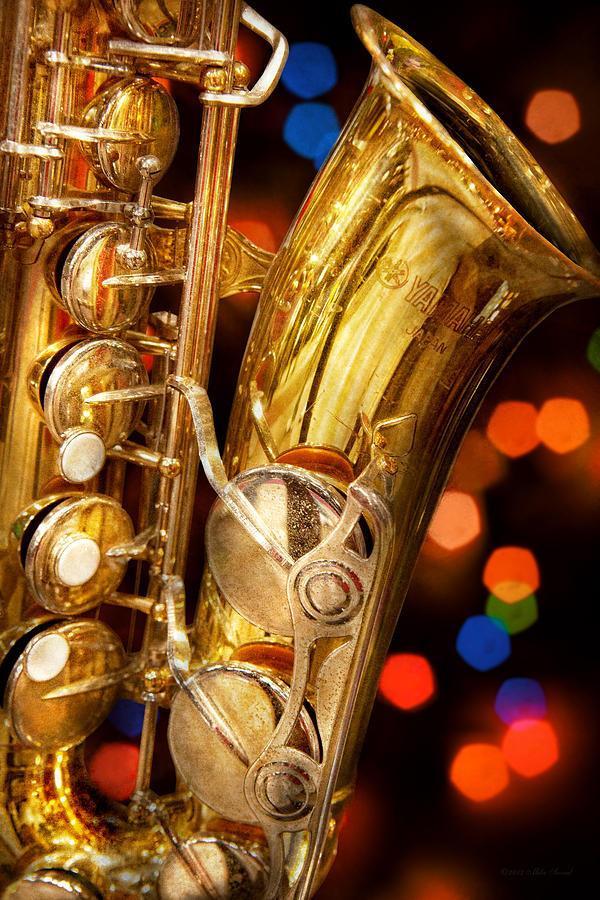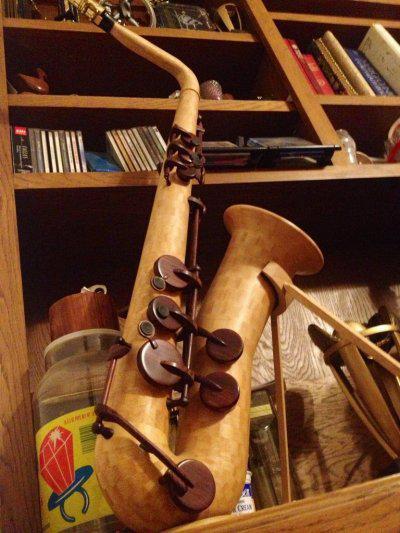The first image is the image on the left, the second image is the image on the right. Analyze the images presented: Is the assertion "An image shows an instrument laying flat on a woodgrain surface." valid? Answer yes or no. No. 